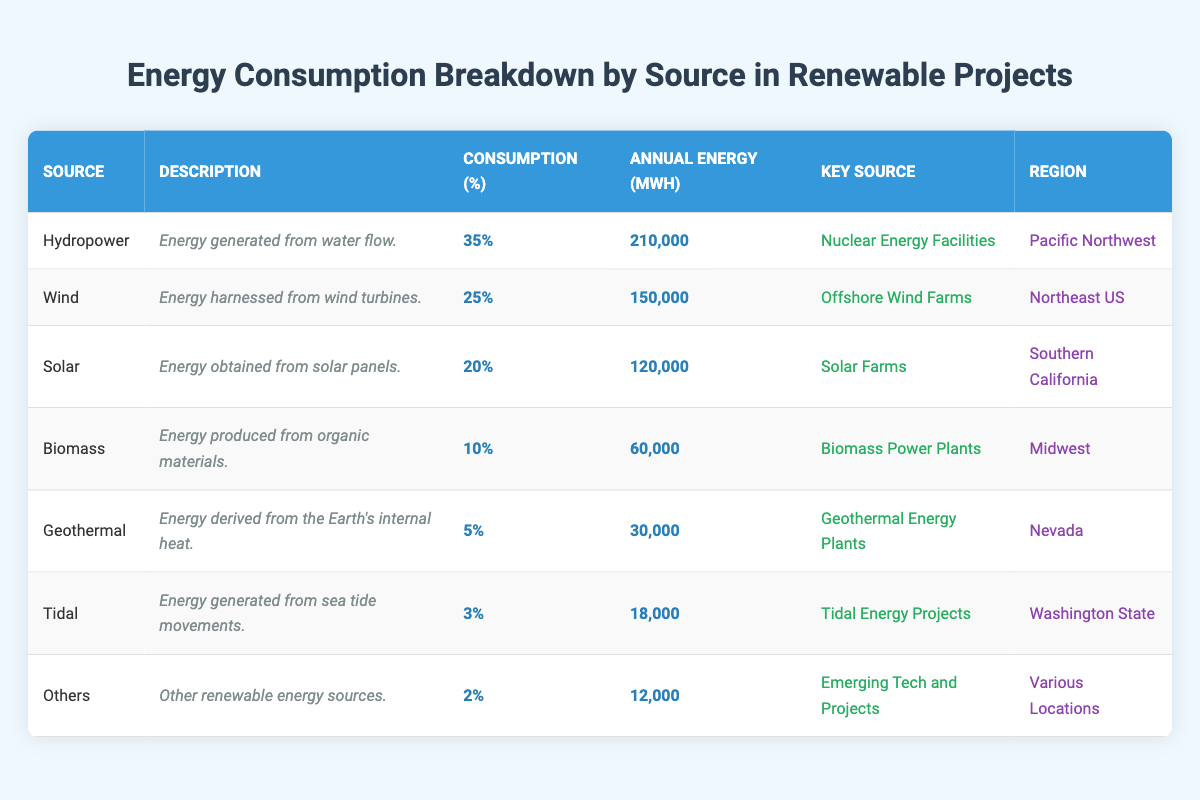What is the consumption percentage of Hydropower? The table lists the consumption percentage for Hydropower as 35%.
Answer: 35% What is the annual energy production from Wind energy? According to the table, the annual energy production from Wind is listed as 150,000 MWh.
Answer: 150,000 MWh Which energy source has the highest annual energy generation? By comparing the annual energy values in the table, Hydropower is the highest at 210,000 MWh.
Answer: Hydropower Is the consumption percentage for Biomass greater than that for Geothermal? The table shows Biomass at 10% and Geothermal at 5%. Since 10% is greater than 5%, the statement is true.
Answer: Yes What is the total annual energy generation from Solar and Biomass combined? Solar has an annual generation of 120,000 MWh and Biomass has 60,000 MWh. Adding these gives 120,000 + 60,000 = 180,000 MWh.
Answer: 180,000 MWh In which region is the key source for Tidal energy located? The table indicates that the key source for Tidal energy is in Washington State.
Answer: Washington State Which energy source accounts for the least percentage of total consumption? The table shows that the Others category accounts for only 2%, which is the smallest percentage.
Answer: Others If you add up the consumption percentages of all sources, what is the total? The total can be calculated by summing individual percentages: 35 + 25 + 20 + 10 + 5 + 3 + 2 = 100%. Therefore, the total consumption percentage is 100%.
Answer: 100% Is Solar the only source with a consumption percentage of 20%? The table indicates that only Solar has a consumption percentage of 20%, making the statement true.
Answer: Yes What is the difference in annual energy production between Hydropower and Tidal? Hydropower produces 210,000 MWh, and Tidal produces 18,000 MWh. The difference is 210,000 - 18,000 = 192,000 MWh.
Answer: 192,000 MWh 